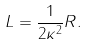Convert formula to latex. <formula><loc_0><loc_0><loc_500><loc_500>L = \frac { 1 } { 2 \kappa ^ { 2 } } R .</formula> 